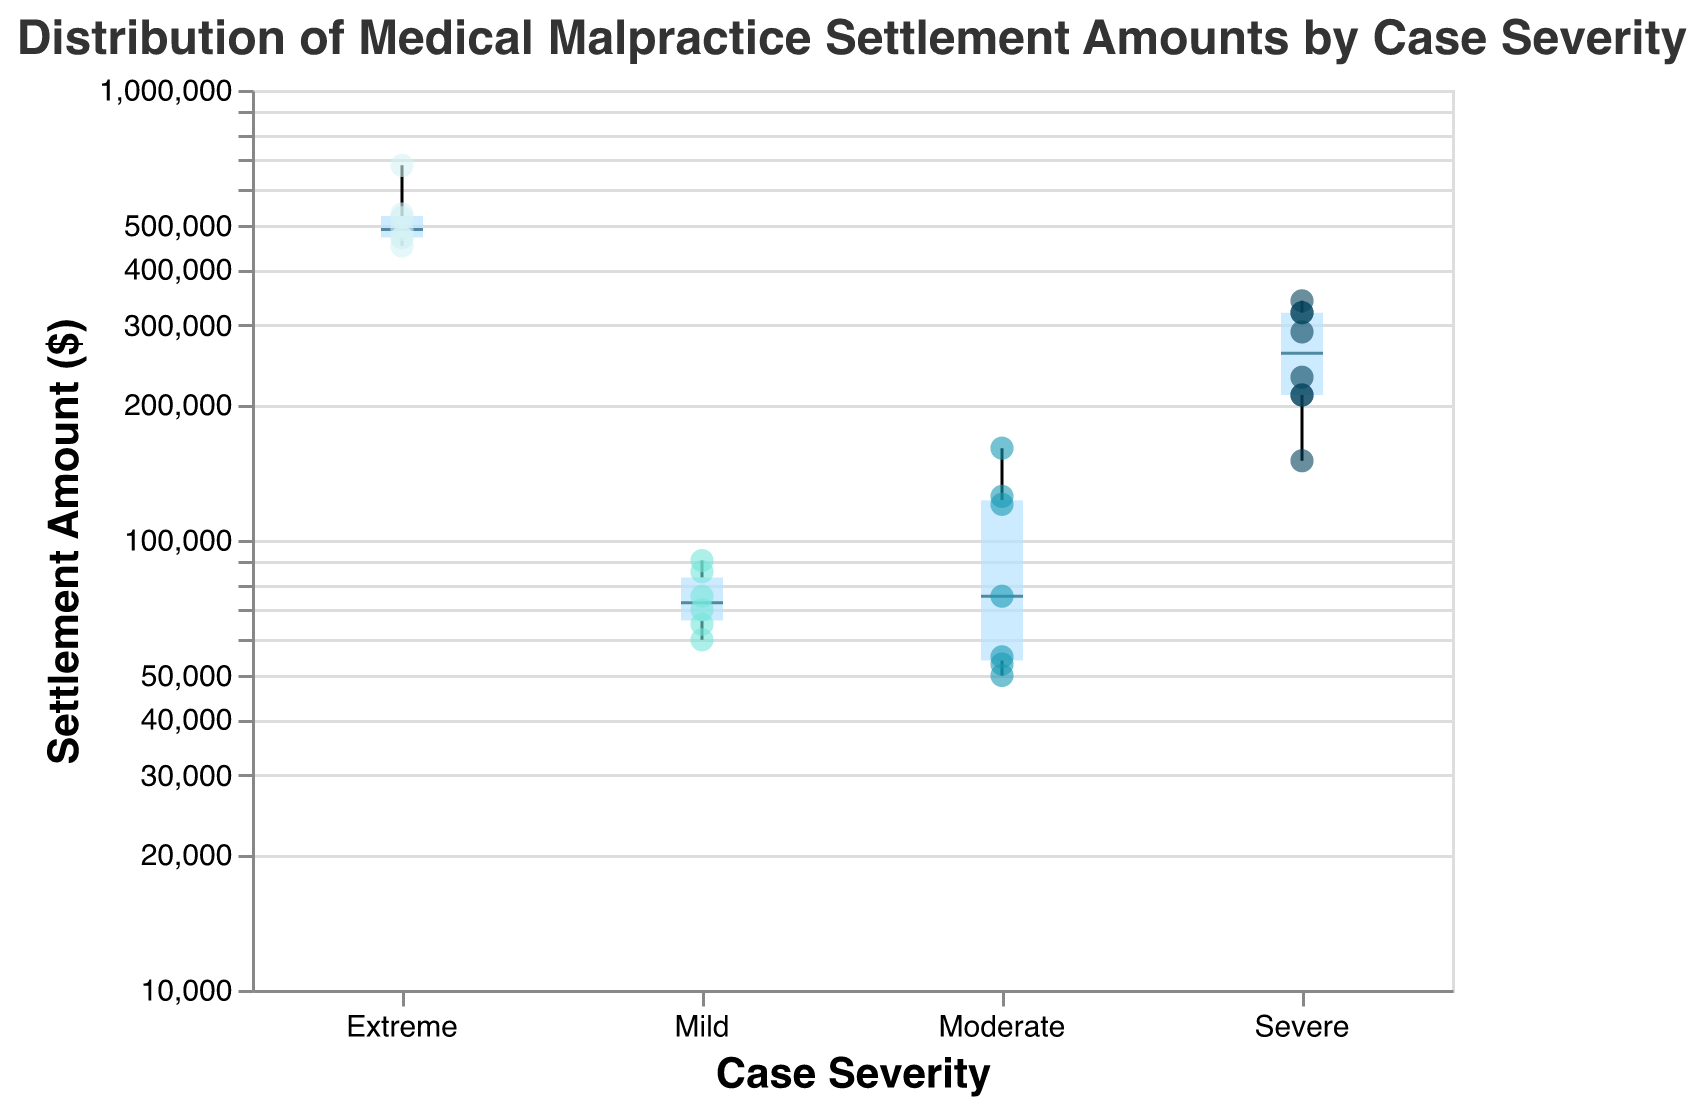What is the title of the figure? The title of the figure is displayed at the top and provides a summary of what the figure represents. The title is "Distribution of Medical Malpractice Settlement Amounts by Case Severity".
Answer: Distribution of Medical Malpractice Settlement Amounts by Case Severity How many case severity categories are there in the figure? The categories can be seen along the x-axis. There are four distinct categories: "Mild," "Moderate," "Severe," and "Extreme".
Answer: 4 What is the median settlement amount for Severe cases? The median value is represented by the horizontal line within the box plot for the Severe category. The median settlement amount can be visually seen from the plot.
Answer: Approximately 270000 Which case severity category has the highest maximum settlement amount? The highest maximum settlement amount is represented by the upper whisker or point in the box plot. This is in the "Extreme" category.
Answer: Extreme Comparing "Mild" and "Extreme" categories, which one has a higher IQR (Interquartile Range)? The IQR is the difference between the upper quartile (Q3) and the lower quartile (Q1), visually represented by the height of the box. The "Extreme" category has a taller box compared to the "Mild" category.
Answer: Extreme In which case severity category is the settlement amount most variable? Variability can be assessed by the range between the minimum and maximum data points within each category. "Extreme" has the largest range indicating the most variability.
Answer: Extreme What is the average settlement amount for Moderate cases based on the data points provided? First, sum the settlement amounts for Moderate cases and then divide by the number of Moderate cases. Sum = 50000 + 75000 + 55000 + 120000 + 53000 + 160000 + 125000 = 638000. There are 7 data points. Average = 638000 / 7 = 91142.86
Answer: 91142.86 Between "Moderate" and "Severe" categories, which one has a higher median settlement amount? The median amount is represented by the line within the box. "Severe" cases have a higher median settlement amount compared to "Moderate" cases.
Answer: Severe What is the log-scale used for the y-axis? The y-axis representing the Settlement Amount is depicted using a logarithmic scale. This is indicated in the specifications of the plot.
Answer: Logarithmic scale 